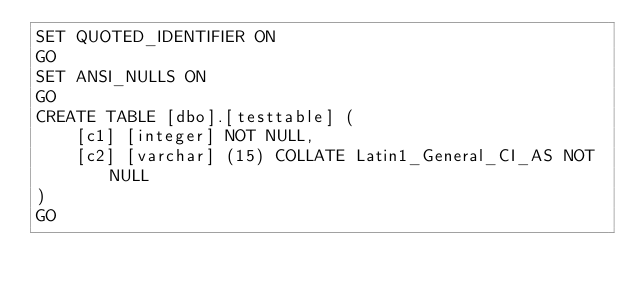Convert code to text. <code><loc_0><loc_0><loc_500><loc_500><_SQL_>SET QUOTED_IDENTIFIER ON
GO
SET ANSI_NULLS ON
GO
CREATE TABLE [dbo].[testtable] (
    [c1] [integer] NOT NULL,
    [c2] [varchar] (15) COLLATE Latin1_General_CI_AS NOT NULL
)
GO
</code> 